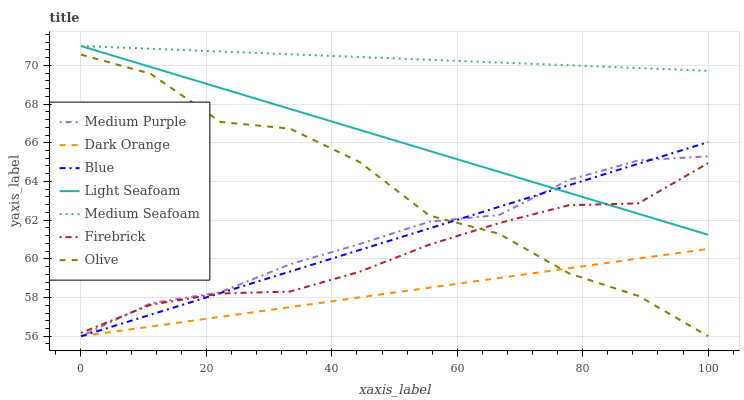Does Dark Orange have the minimum area under the curve?
Answer yes or no. Yes. Does Medium Seafoam have the maximum area under the curve?
Answer yes or no. Yes. Does Firebrick have the minimum area under the curve?
Answer yes or no. No. Does Firebrick have the maximum area under the curve?
Answer yes or no. No. Is Blue the smoothest?
Answer yes or no. Yes. Is Olive the roughest?
Answer yes or no. Yes. Is Dark Orange the smoothest?
Answer yes or no. No. Is Dark Orange the roughest?
Answer yes or no. No. Does Blue have the lowest value?
Answer yes or no. Yes. Does Firebrick have the lowest value?
Answer yes or no. No. Does Medium Seafoam have the highest value?
Answer yes or no. Yes. Does Firebrick have the highest value?
Answer yes or no. No. Is Medium Purple less than Medium Seafoam?
Answer yes or no. Yes. Is Firebrick greater than Dark Orange?
Answer yes or no. Yes. Does Medium Purple intersect Dark Orange?
Answer yes or no. Yes. Is Medium Purple less than Dark Orange?
Answer yes or no. No. Is Medium Purple greater than Dark Orange?
Answer yes or no. No. Does Medium Purple intersect Medium Seafoam?
Answer yes or no. No. 